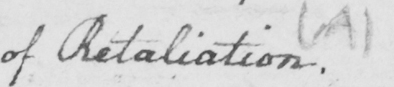Please transcribe the handwritten text in this image. of Retaliation .  ( A ) 